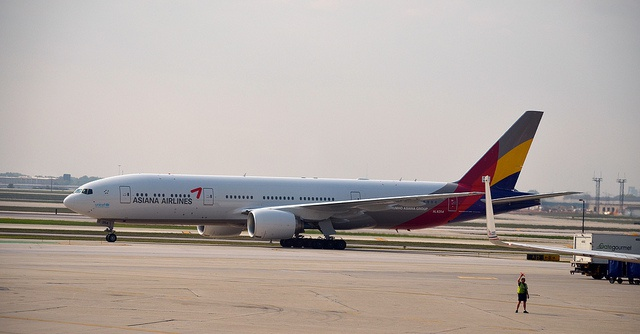Describe the objects in this image and their specific colors. I can see airplane in darkgray, black, and gray tones, truck in darkgray, gray, black, and tan tones, and people in darkgray, black, maroon, gray, and darkgreen tones in this image. 